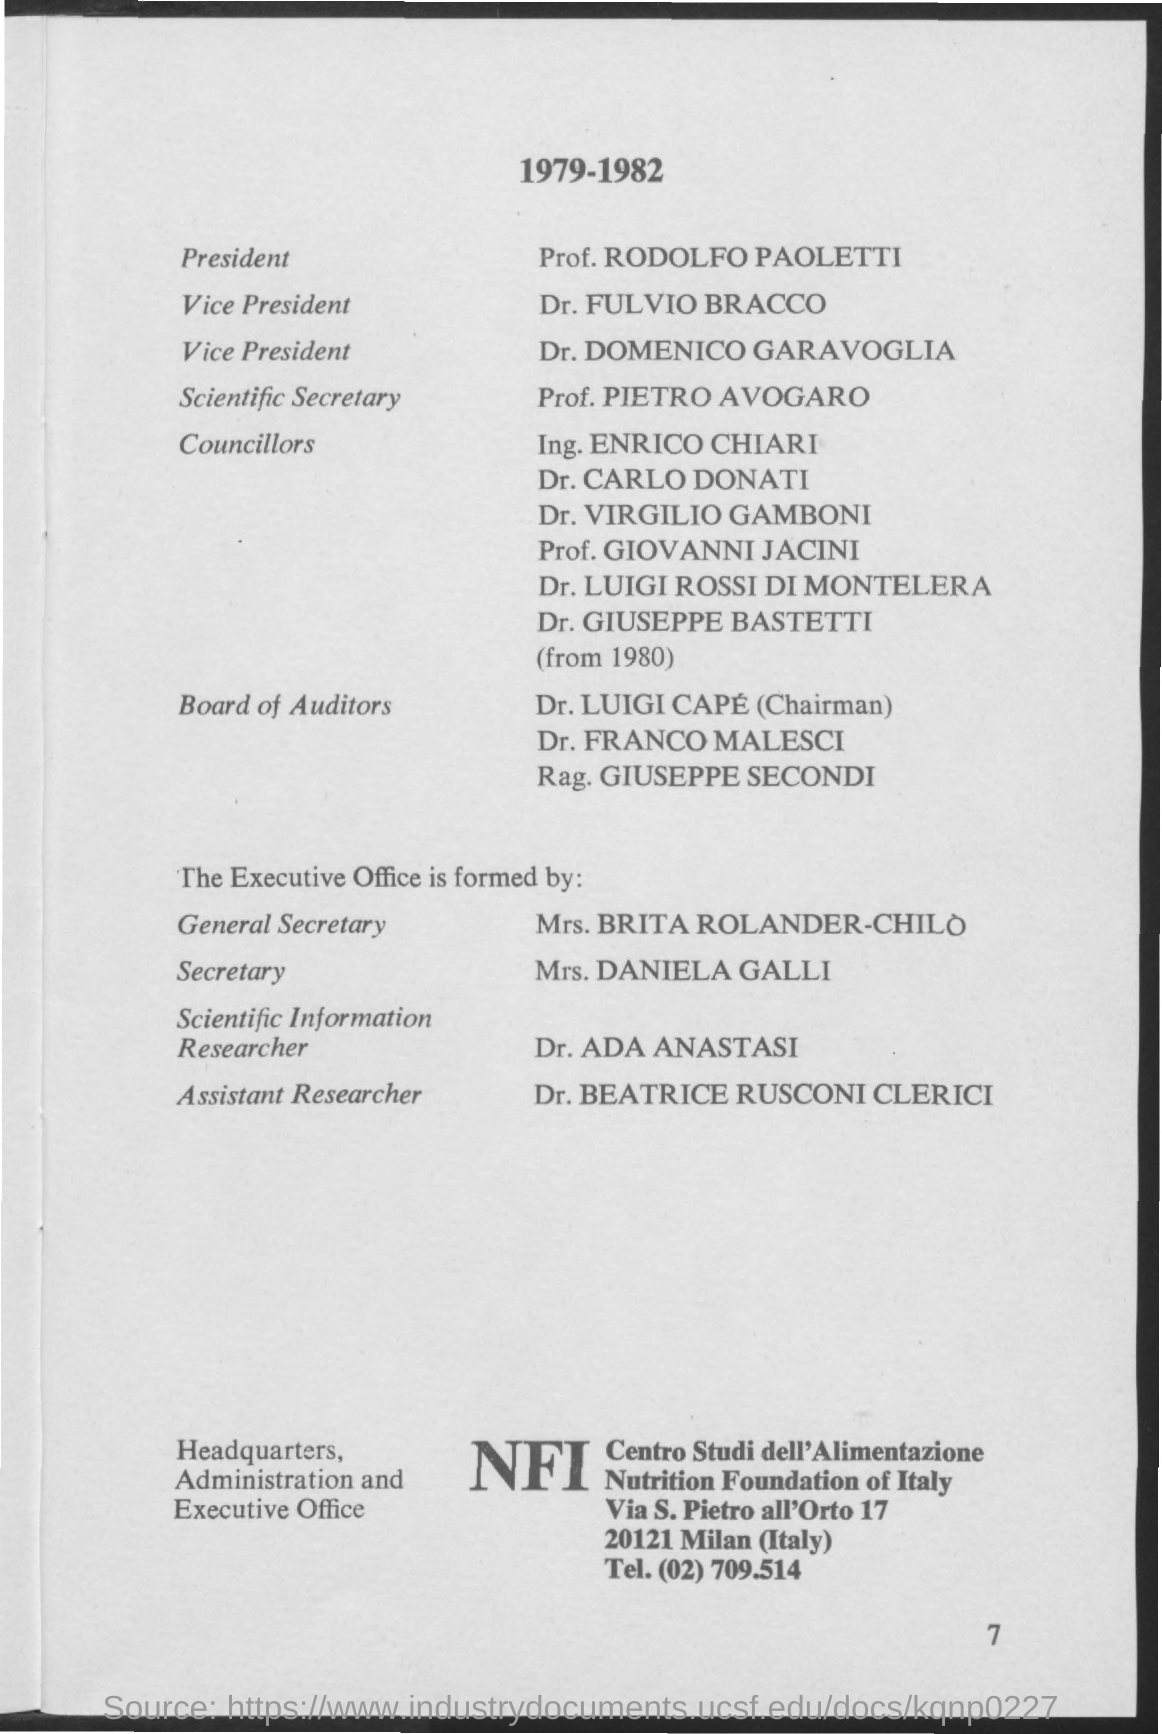Who is the President?
Your response must be concise. Prof. RODOLFO PAOLETTI. Who is the Scientific Secretary?
Your answer should be compact. Prof. Pietro Avogaro. Who is the Secretary?
Provide a succinct answer. Mrs. Daniela Galli. 